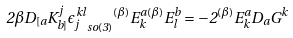<formula> <loc_0><loc_0><loc_500><loc_500>2 \beta D _ { [ a } K ^ { j } _ { b ] } { \epsilon _ { j } ^ { \, k l } } _ { s o ( 3 ) } { ^ { ( \beta ) } E ^ { a } _ { k } } { ^ { ( \beta ) } E ^ { b } _ { l } } = - 2 ^ { ( \beta ) } E ^ { a } _ { k } D _ { a } G ^ { k }</formula> 